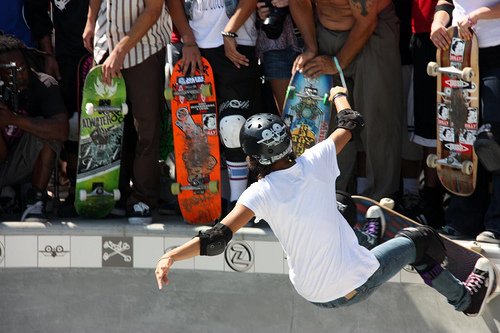Identify the text displayed in this image. ATWATERO 